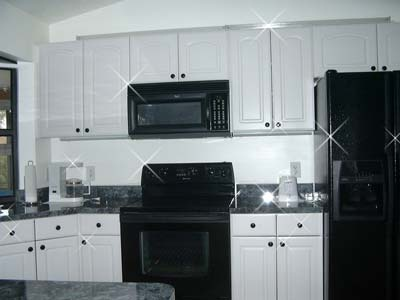Describe the objects in this image and their specific colors. I can see refrigerator in gray, black, and darkgray tones, oven in gray, black, purple, and darkgray tones, microwave in gray, black, purple, and darkblue tones, dining table in gray, black, darkgray, and purple tones, and bottle in gray, darkgray, and lightgray tones in this image. 